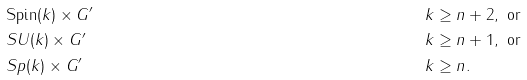Convert formula to latex. <formula><loc_0><loc_0><loc_500><loc_500>& \text {Spin} ( k ) \times G ^ { \prime } & k & \geq n + 2 , \text { or} \\ & S U ( k ) \times G ^ { \prime } & k & \geq n + 1 , \text { or} \\ & S p ( k ) \times G ^ { \prime } & k & \geq n .</formula> 